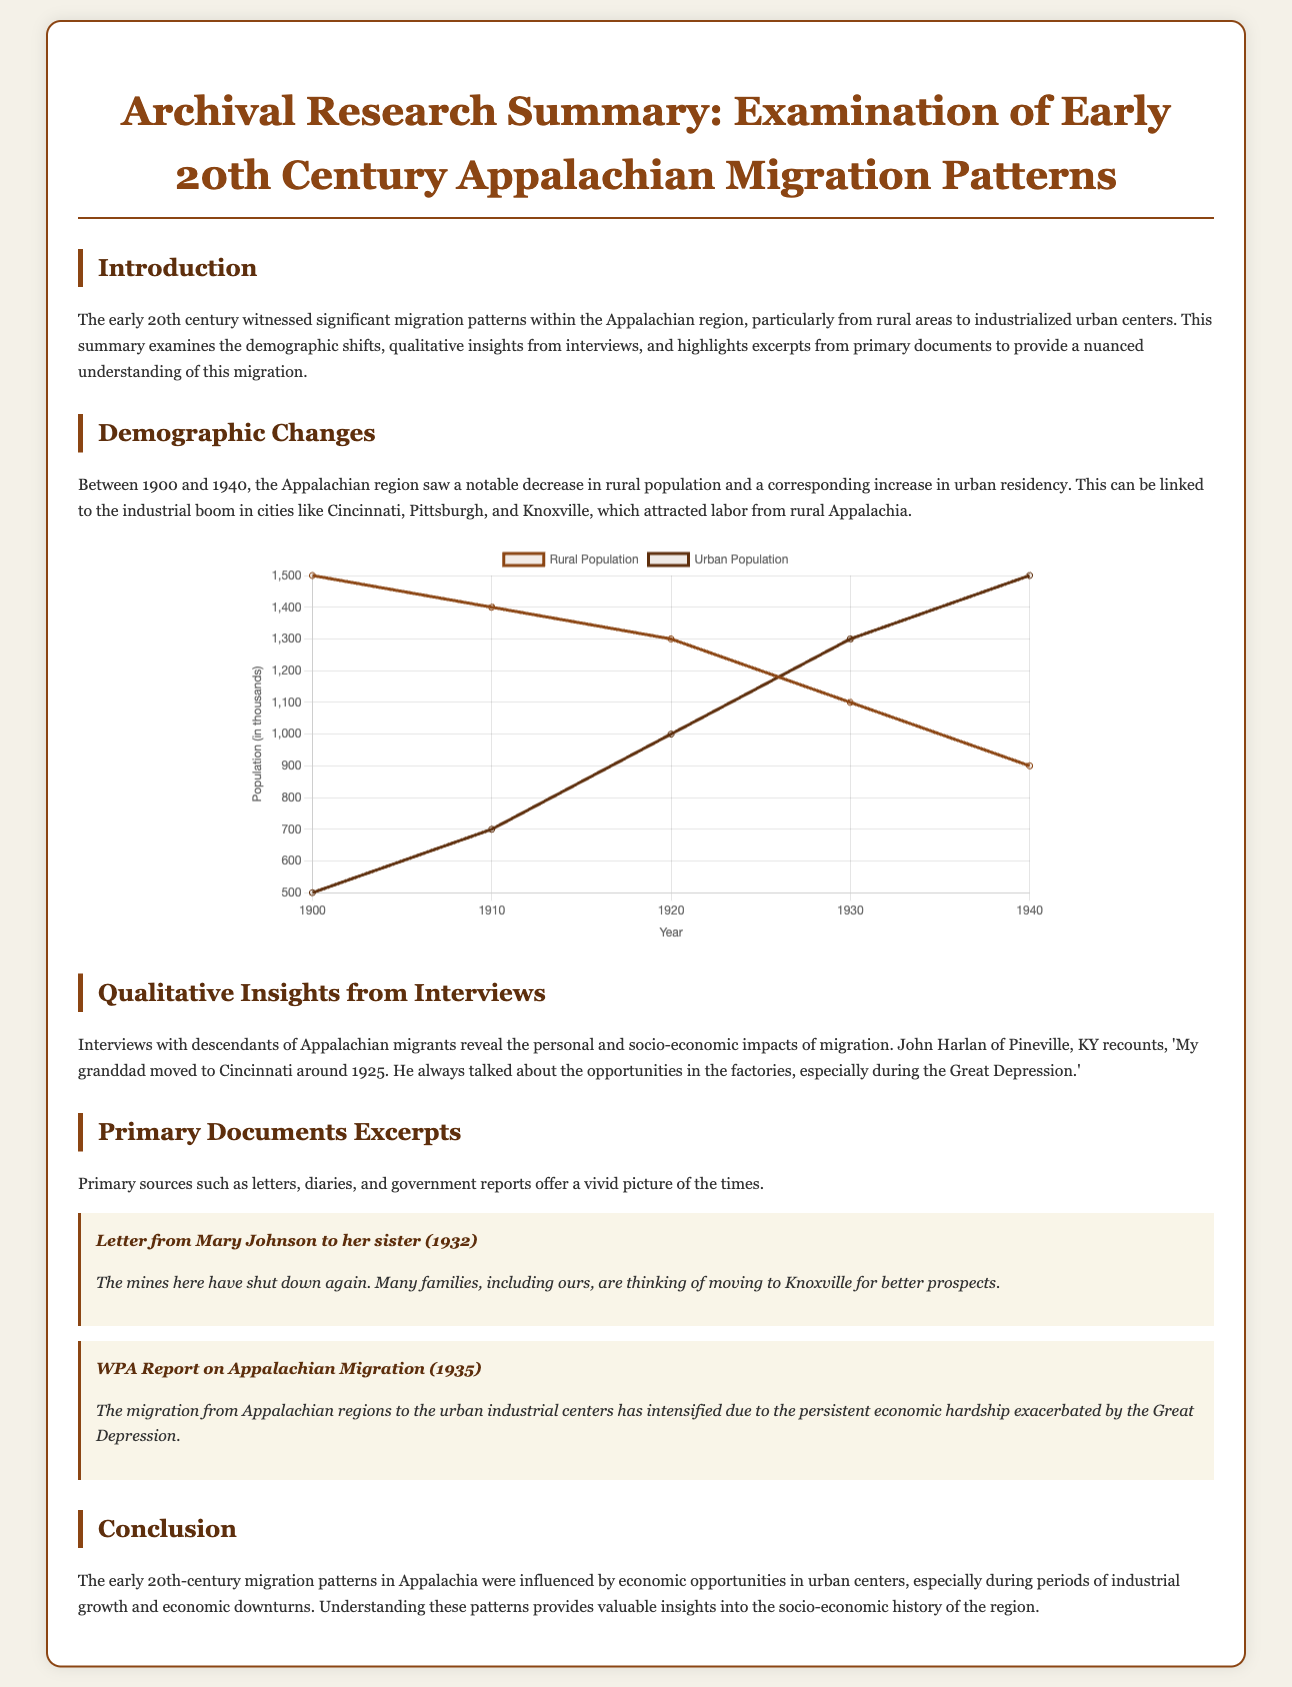what is the title of the document? The title is found prominently at the top of the document and summarizes the research focus.
Answer: Archival Research Summary: Examination of Early 20th Century Appalachian Migration Patterns what years are analyzed in the document? The years analyzed are stated in the introduction as well as labeled on the chart.
Answer: 1900 to 1940 who is quoted in the qualitative insights section? The interviewee is explicitly mentioned in the qualitative insights section.
Answer: John Harlan what is the rural population in 1930 according to the chart? The population figure for 1930 is clearly indicated on the chart.
Answer: 1100 which city is mentioned as an attractive destination for migrants? The city is referenced in the demographic changes and qualitative sections.
Answer: Cincinnati what is the main reason for migration mentioned in the excerpts? The main reason is emphasized in the excerpts from the primary documents.
Answer: Economic hardship what type of document is this summary categorized under? The categorization of the document type is stated at the beginning.
Answer: Datasheet what significant event is noted in the qualitative insights impacting migration? The event is mentioned in relation to economic opportunities and its effect on families.
Answer: Great Depression 